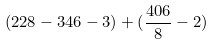Convert formula to latex. <formula><loc_0><loc_0><loc_500><loc_500>( 2 2 8 - 3 4 6 - 3 ) + ( \frac { 4 0 6 } { 8 } - 2 )</formula> 